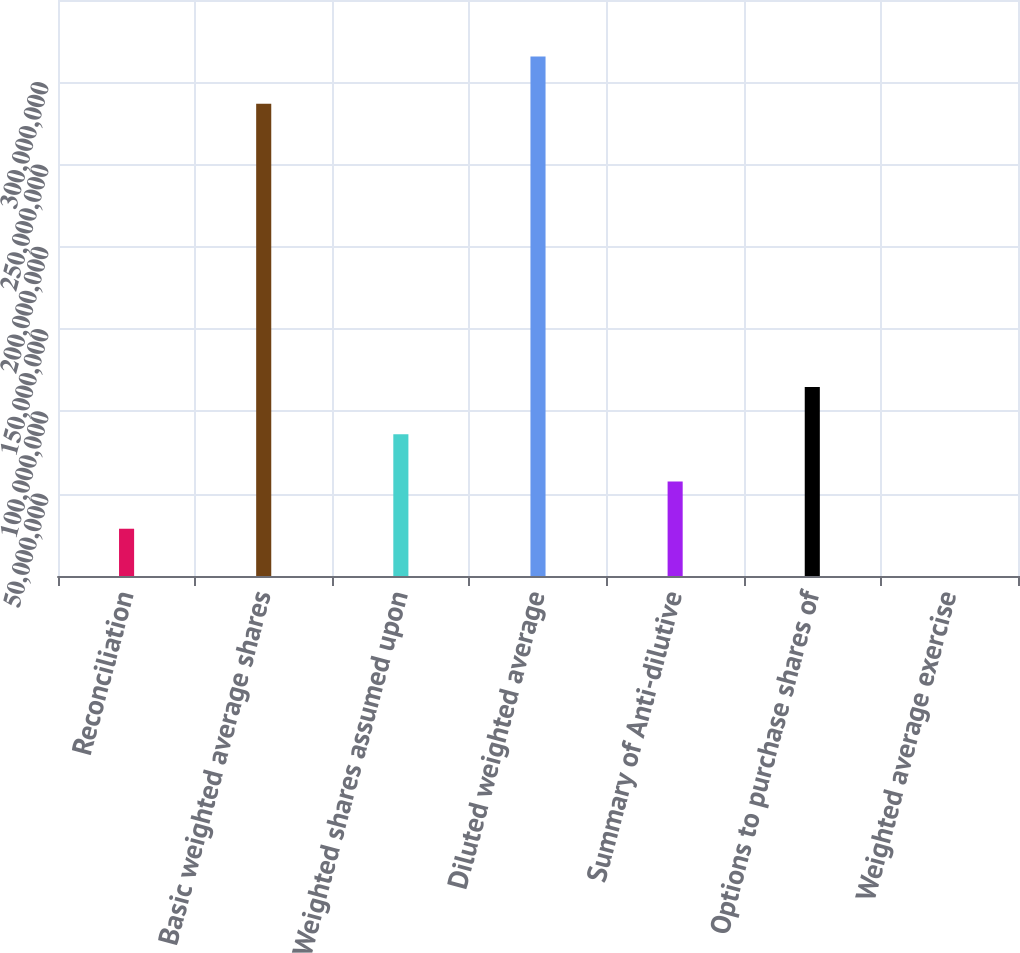<chart> <loc_0><loc_0><loc_500><loc_500><bar_chart><fcel>Reconciliation<fcel>Basic weighted average shares<fcel>Weighted shares assumed upon<fcel>Diluted weighted average<fcel>Summary of Anti-dilutive<fcel>Options to purchase shares of<fcel>Weighted average exercise<nl><fcel>2.87163e+07<fcel>2.86967e+08<fcel>8.61489e+07<fcel>3.15683e+08<fcel>5.74326e+07<fcel>1.14865e+08<fcel>55.02<nl></chart> 